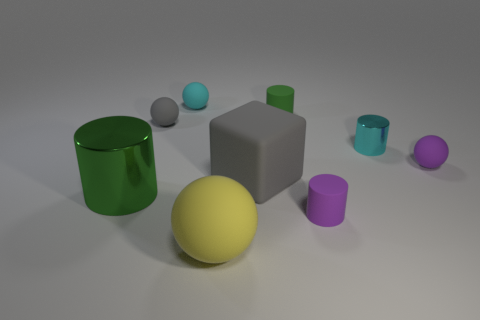What shape is the shiny object that is right of the small purple matte cylinder?
Your answer should be compact. Cylinder. The cyan object that is to the left of the small cyan thing that is on the right side of the small matte thing that is behind the small green matte cylinder is what shape?
Your response must be concise. Sphere. How many things are either purple spheres or blue metallic things?
Give a very brief answer. 1. Is the shape of the cyan object behind the small green rubber cylinder the same as the matte thing that is to the left of the small cyan matte ball?
Provide a short and direct response. Yes. What number of small things are on the right side of the small gray matte thing and behind the purple matte sphere?
Your response must be concise. 3. What number of other things are there of the same size as the green matte cylinder?
Your answer should be compact. 5. What is the small ball that is in front of the small green matte cylinder and behind the small purple matte ball made of?
Your answer should be compact. Rubber. Do the large metallic thing and the tiny matte cylinder behind the tiny purple ball have the same color?
Make the answer very short. Yes. What size is the green metal thing that is the same shape as the tiny green matte thing?
Provide a short and direct response. Large. What is the shape of the big object that is both on the right side of the tiny cyan rubber object and behind the yellow ball?
Keep it short and to the point. Cube. 